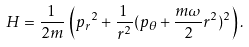Convert formula to latex. <formula><loc_0><loc_0><loc_500><loc_500>H = \frac { 1 } { 2 m } \, \left ( { { p } _ { r } } ^ { 2 } + \frac { 1 } { r ^ { 2 } } ( { p } _ { \theta } + \frac { m \omega } { 2 } r ^ { 2 } ) ^ { 2 } \right ) .</formula> 